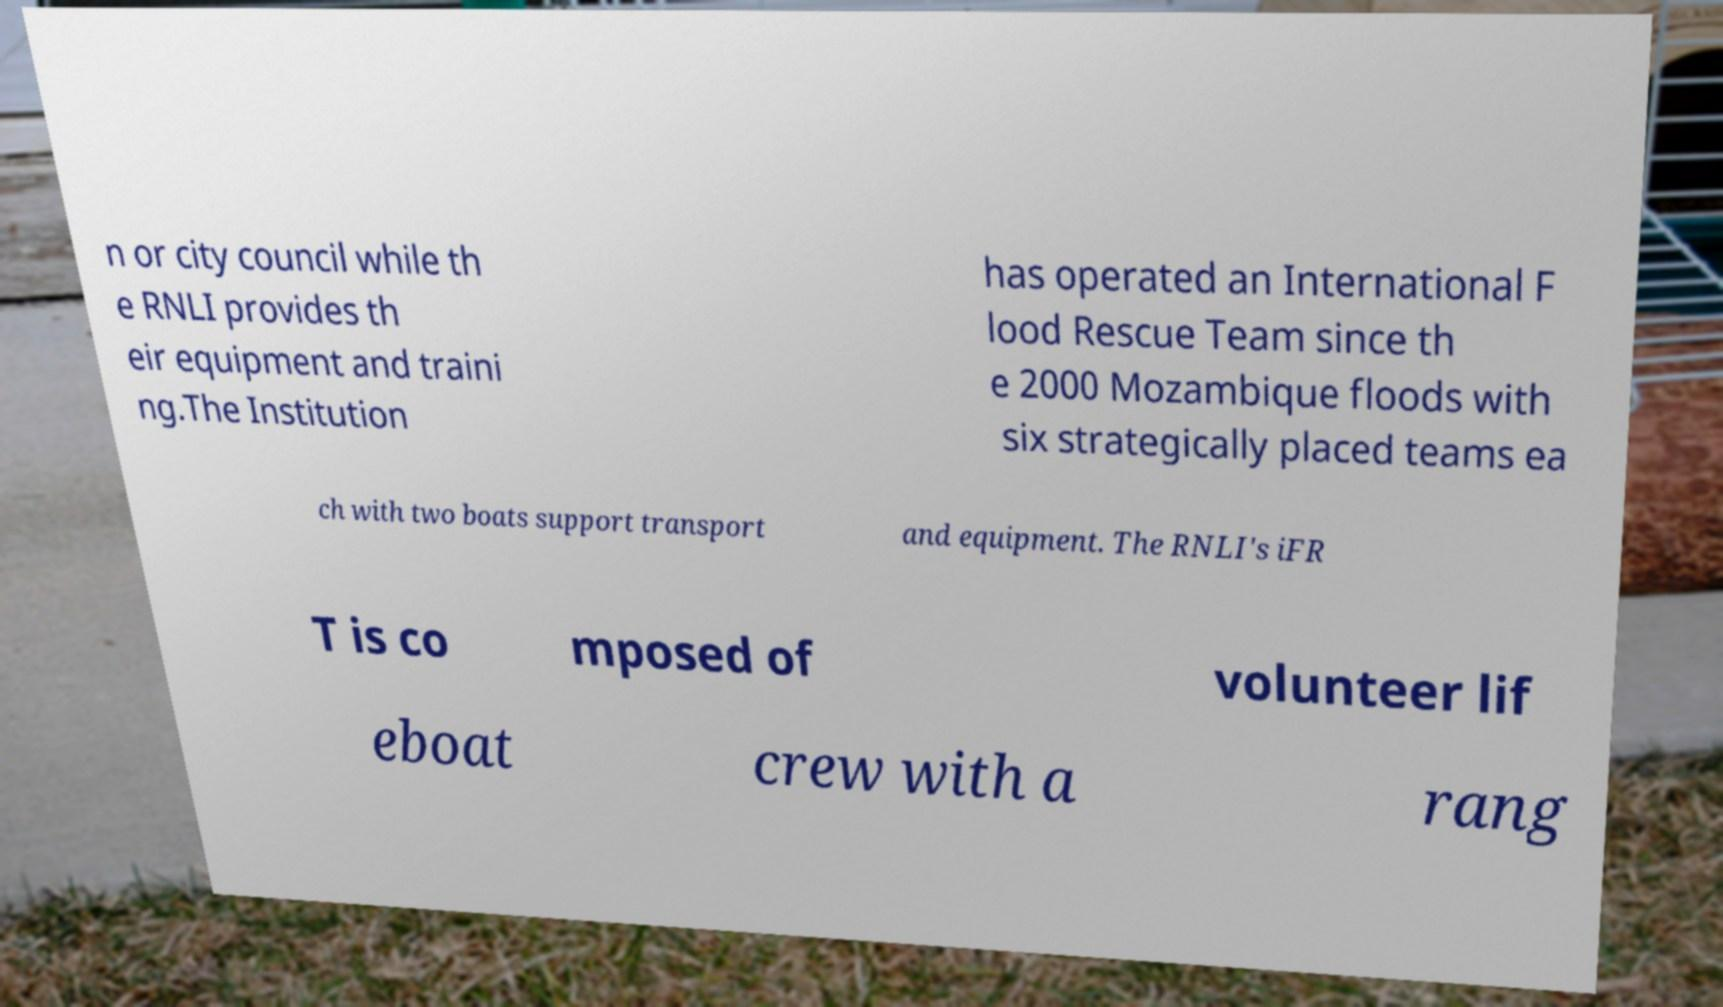Please identify and transcribe the text found in this image. n or city council while th e RNLI provides th eir equipment and traini ng.The Institution has operated an International F lood Rescue Team since th e 2000 Mozambique floods with six strategically placed teams ea ch with two boats support transport and equipment. The RNLI's iFR T is co mposed of volunteer lif eboat crew with a rang 